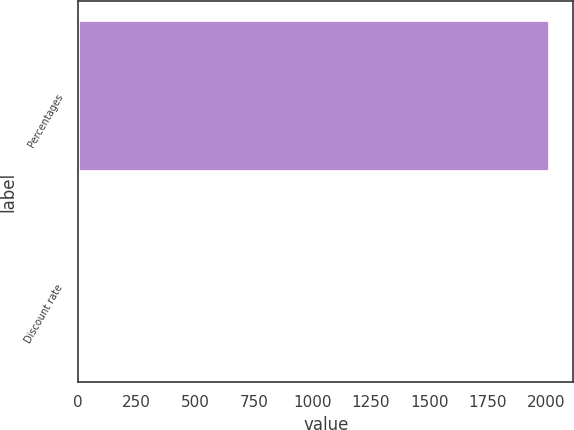<chart> <loc_0><loc_0><loc_500><loc_500><bar_chart><fcel>Percentages<fcel>Discount rate<nl><fcel>2015<fcel>3.63<nl></chart> 